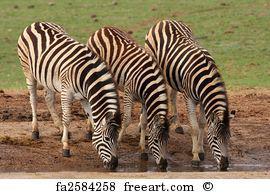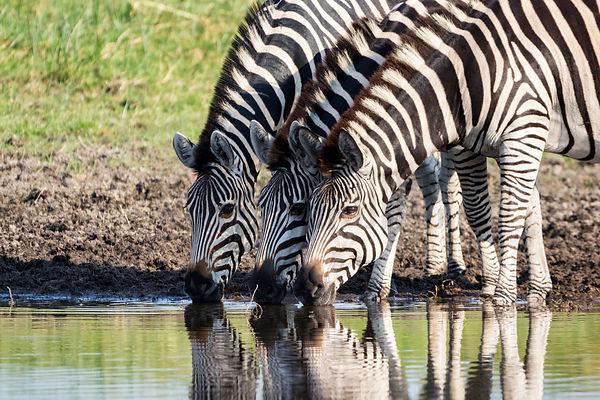The first image is the image on the left, the second image is the image on the right. For the images shown, is this caption "Each image features a group of zebras lined up in a symmetrical fashion" true? Answer yes or no. Yes. The first image is the image on the left, the second image is the image on the right. Considering the images on both sides, is "Each image contains three zebras in a neat row, and the zebras in the left and right images are in similar body poses but facing different directions." valid? Answer yes or no. Yes. 